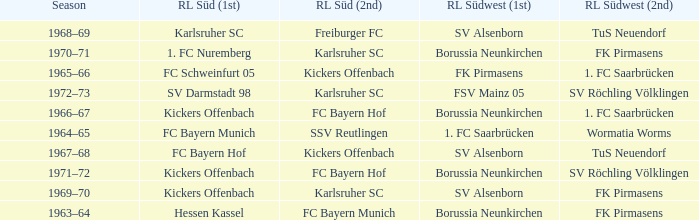What season was Freiburger FC the RL Süd (2nd) team? 1968–69. 